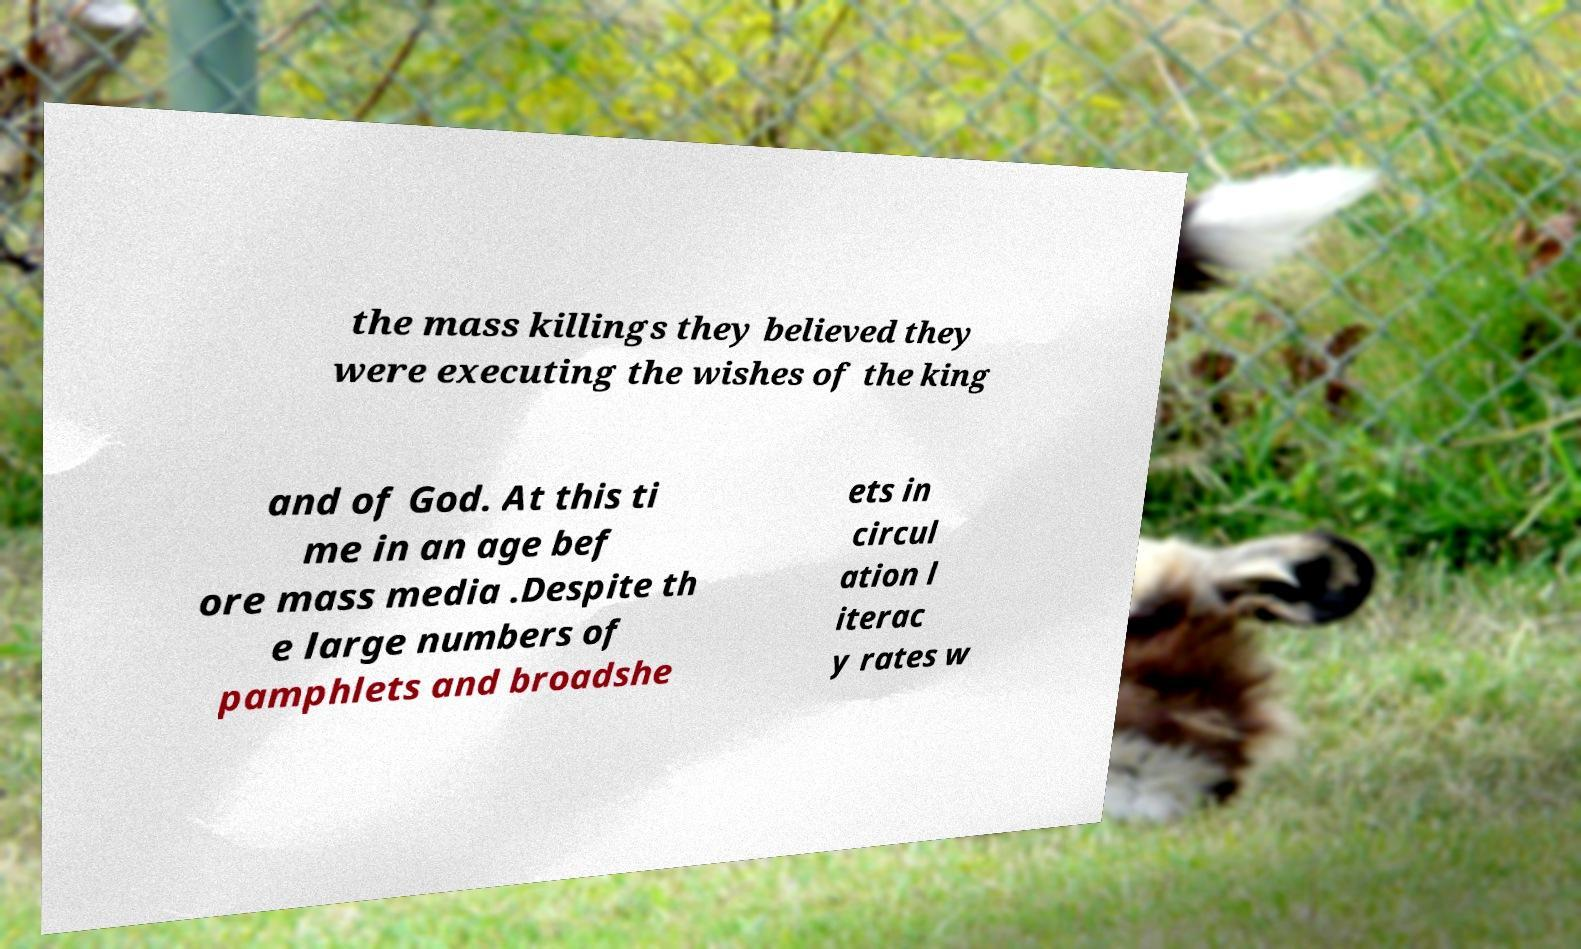Could you extract and type out the text from this image? the mass killings they believed they were executing the wishes of the king and of God. At this ti me in an age bef ore mass media .Despite th e large numbers of pamphlets and broadshe ets in circul ation l iterac y rates w 